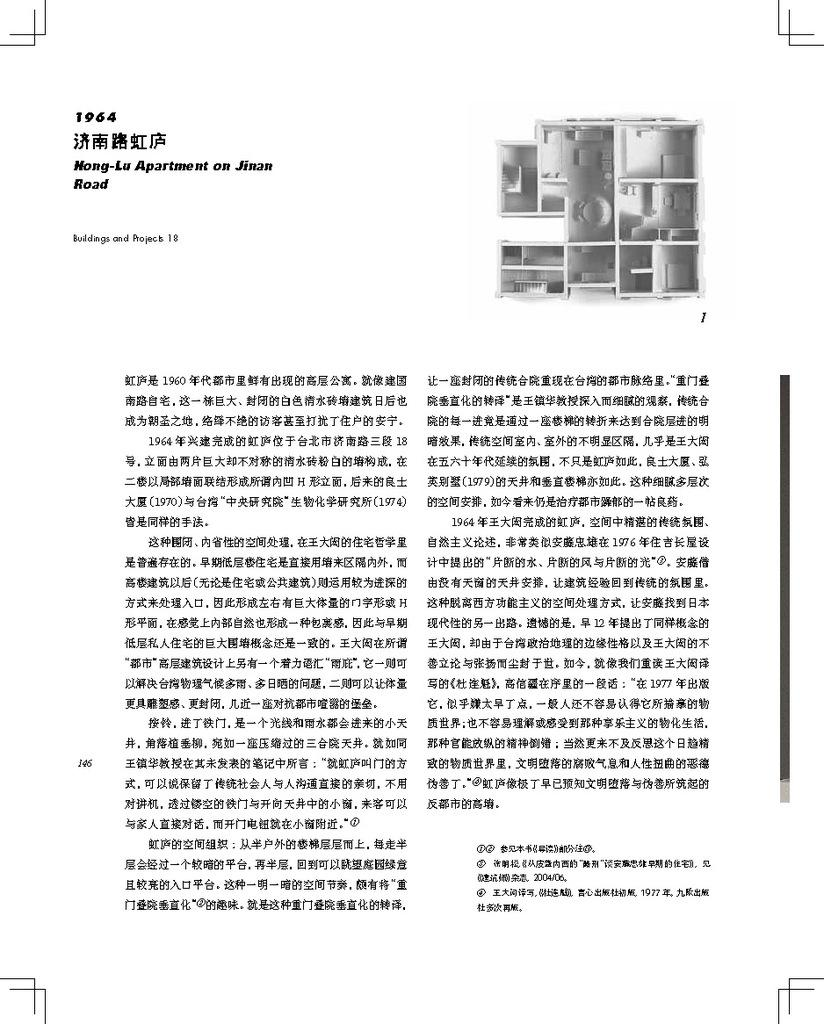<image>
Create a compact narrative representing the image presented. A white piece of paper describing the floor plan for Hong Lu apartment. 